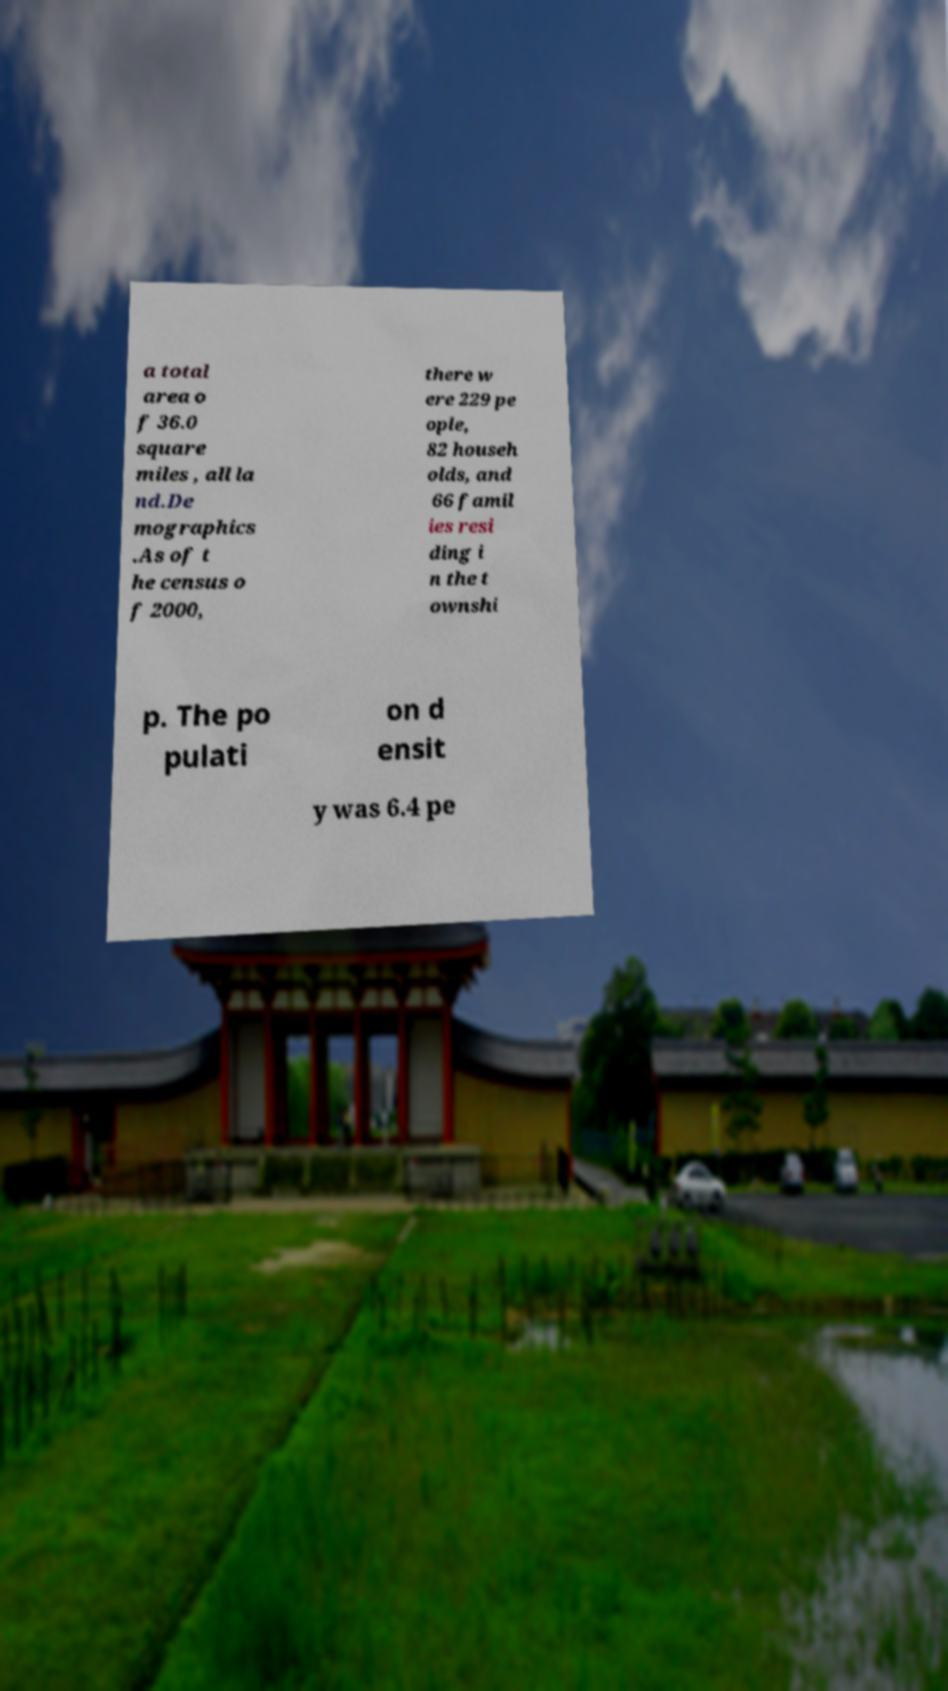Could you extract and type out the text from this image? a total area o f 36.0 square miles , all la nd.De mographics .As of t he census o f 2000, there w ere 229 pe ople, 82 househ olds, and 66 famil ies resi ding i n the t ownshi p. The po pulati on d ensit y was 6.4 pe 